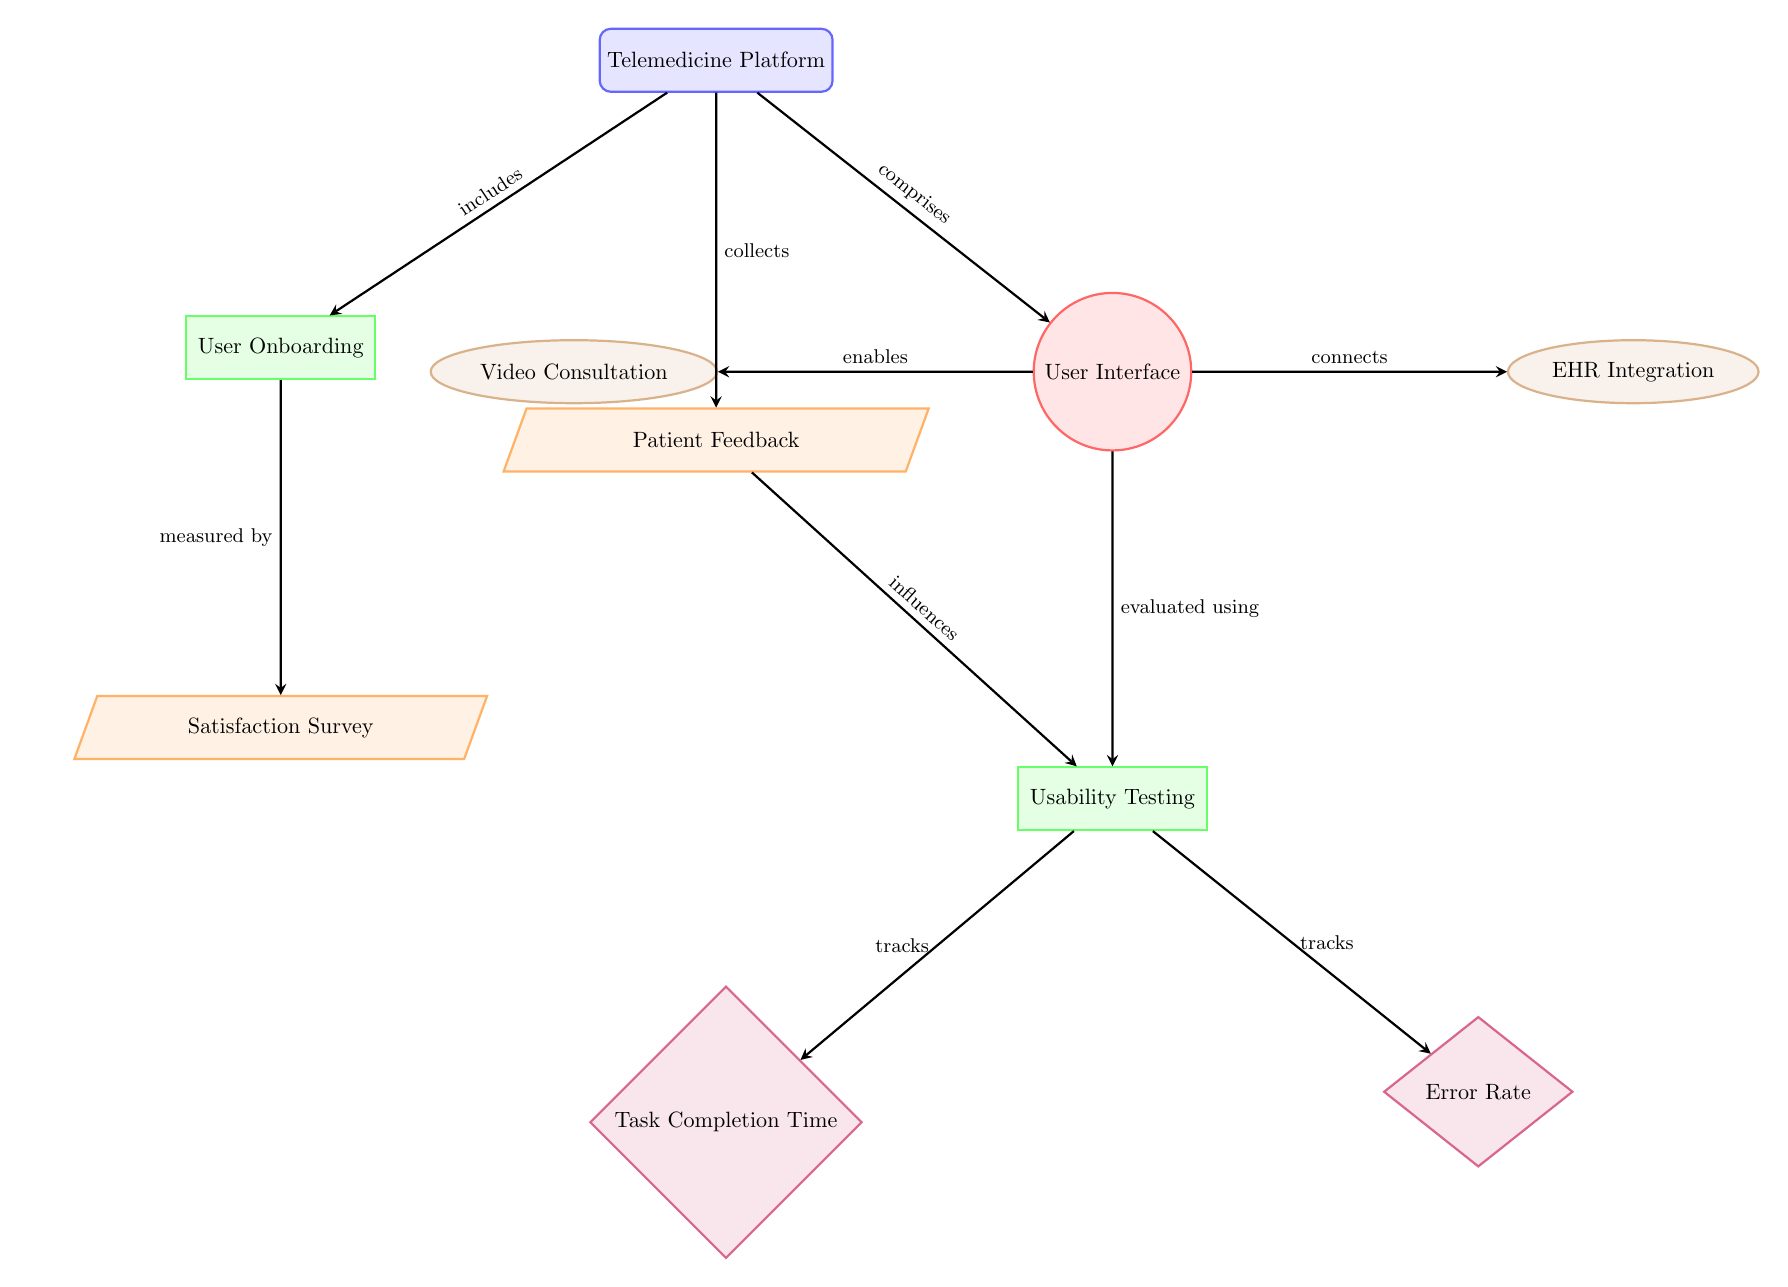What is the main component of the diagram? The main component in the diagram is the "Telemedicine Platform," which is represented at the top of the diagram. This entity is the starting point from which other processes and components branch out.
Answer: Telemedicine Platform How many data nodes are present in the diagram? There are two data nodes in the diagram: "Patient Feedback" and "Satisfaction Survey." These nodes are illustrated below the main "Telemedicine Platform" entity and represent collected information.
Answer: 2 What process is used to evaluate the User Interface? The process used to evaluate the User Interface is "Usability Testing," which is positioned below the "User Interface" component in the diagram, indicating that this evaluation is a focused analysis of user interaction.
Answer: Usability Testing What metric tracks "Error Rate"? The "Error Rate" is tracked by the "Usability Testing" process, as shown in the diagram. This relationship indicates that usability testing aims to measure and reduce errors during user interaction with the platform.
Answer: Usability Testing What feature is connected to the User Interface and also enables video consultations? The feature that enables video consultations is "Video Consultation," which is connected to the User Interface. This shows that the platform includes this capability as part of its user interface features.
Answer: Video Consultation How does "Patient Feedback" influence usability testing? The "Patient Feedback" node influences "Usability Testing" by providing insights from users' experiences, which inform how the usability of the platform is assessed and improved. This arrow indicates a direct influence on the evaluation process.
Answer: Influences What does the "User Onboarding" process measure? The "User Onboarding" process measures the "Satisfaction Survey," which indicates that the platform evaluates how successfully new users are integrated and their initial experiences are captured for feedback.
Answer: Satisfaction Survey Which feature connects the User Interface to Electronic Health Records? The feature that connects to Electronic Health Records (EHR) is "EHR Integration." This shows that the User Interface allows for a connection to EHR systems, enhancing functionality for healthcare providers.
Answer: EHR Integration 